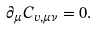<formula> <loc_0><loc_0><loc_500><loc_500>\partial _ { \mu } C _ { v , \mu \nu } = 0 .</formula> 